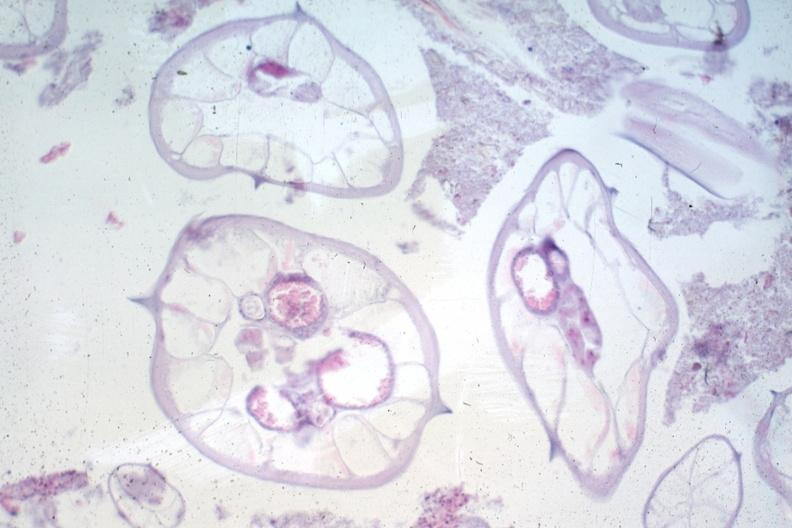what does this image show?
Answer the question using a single word or phrase. Worms no appendix structures 